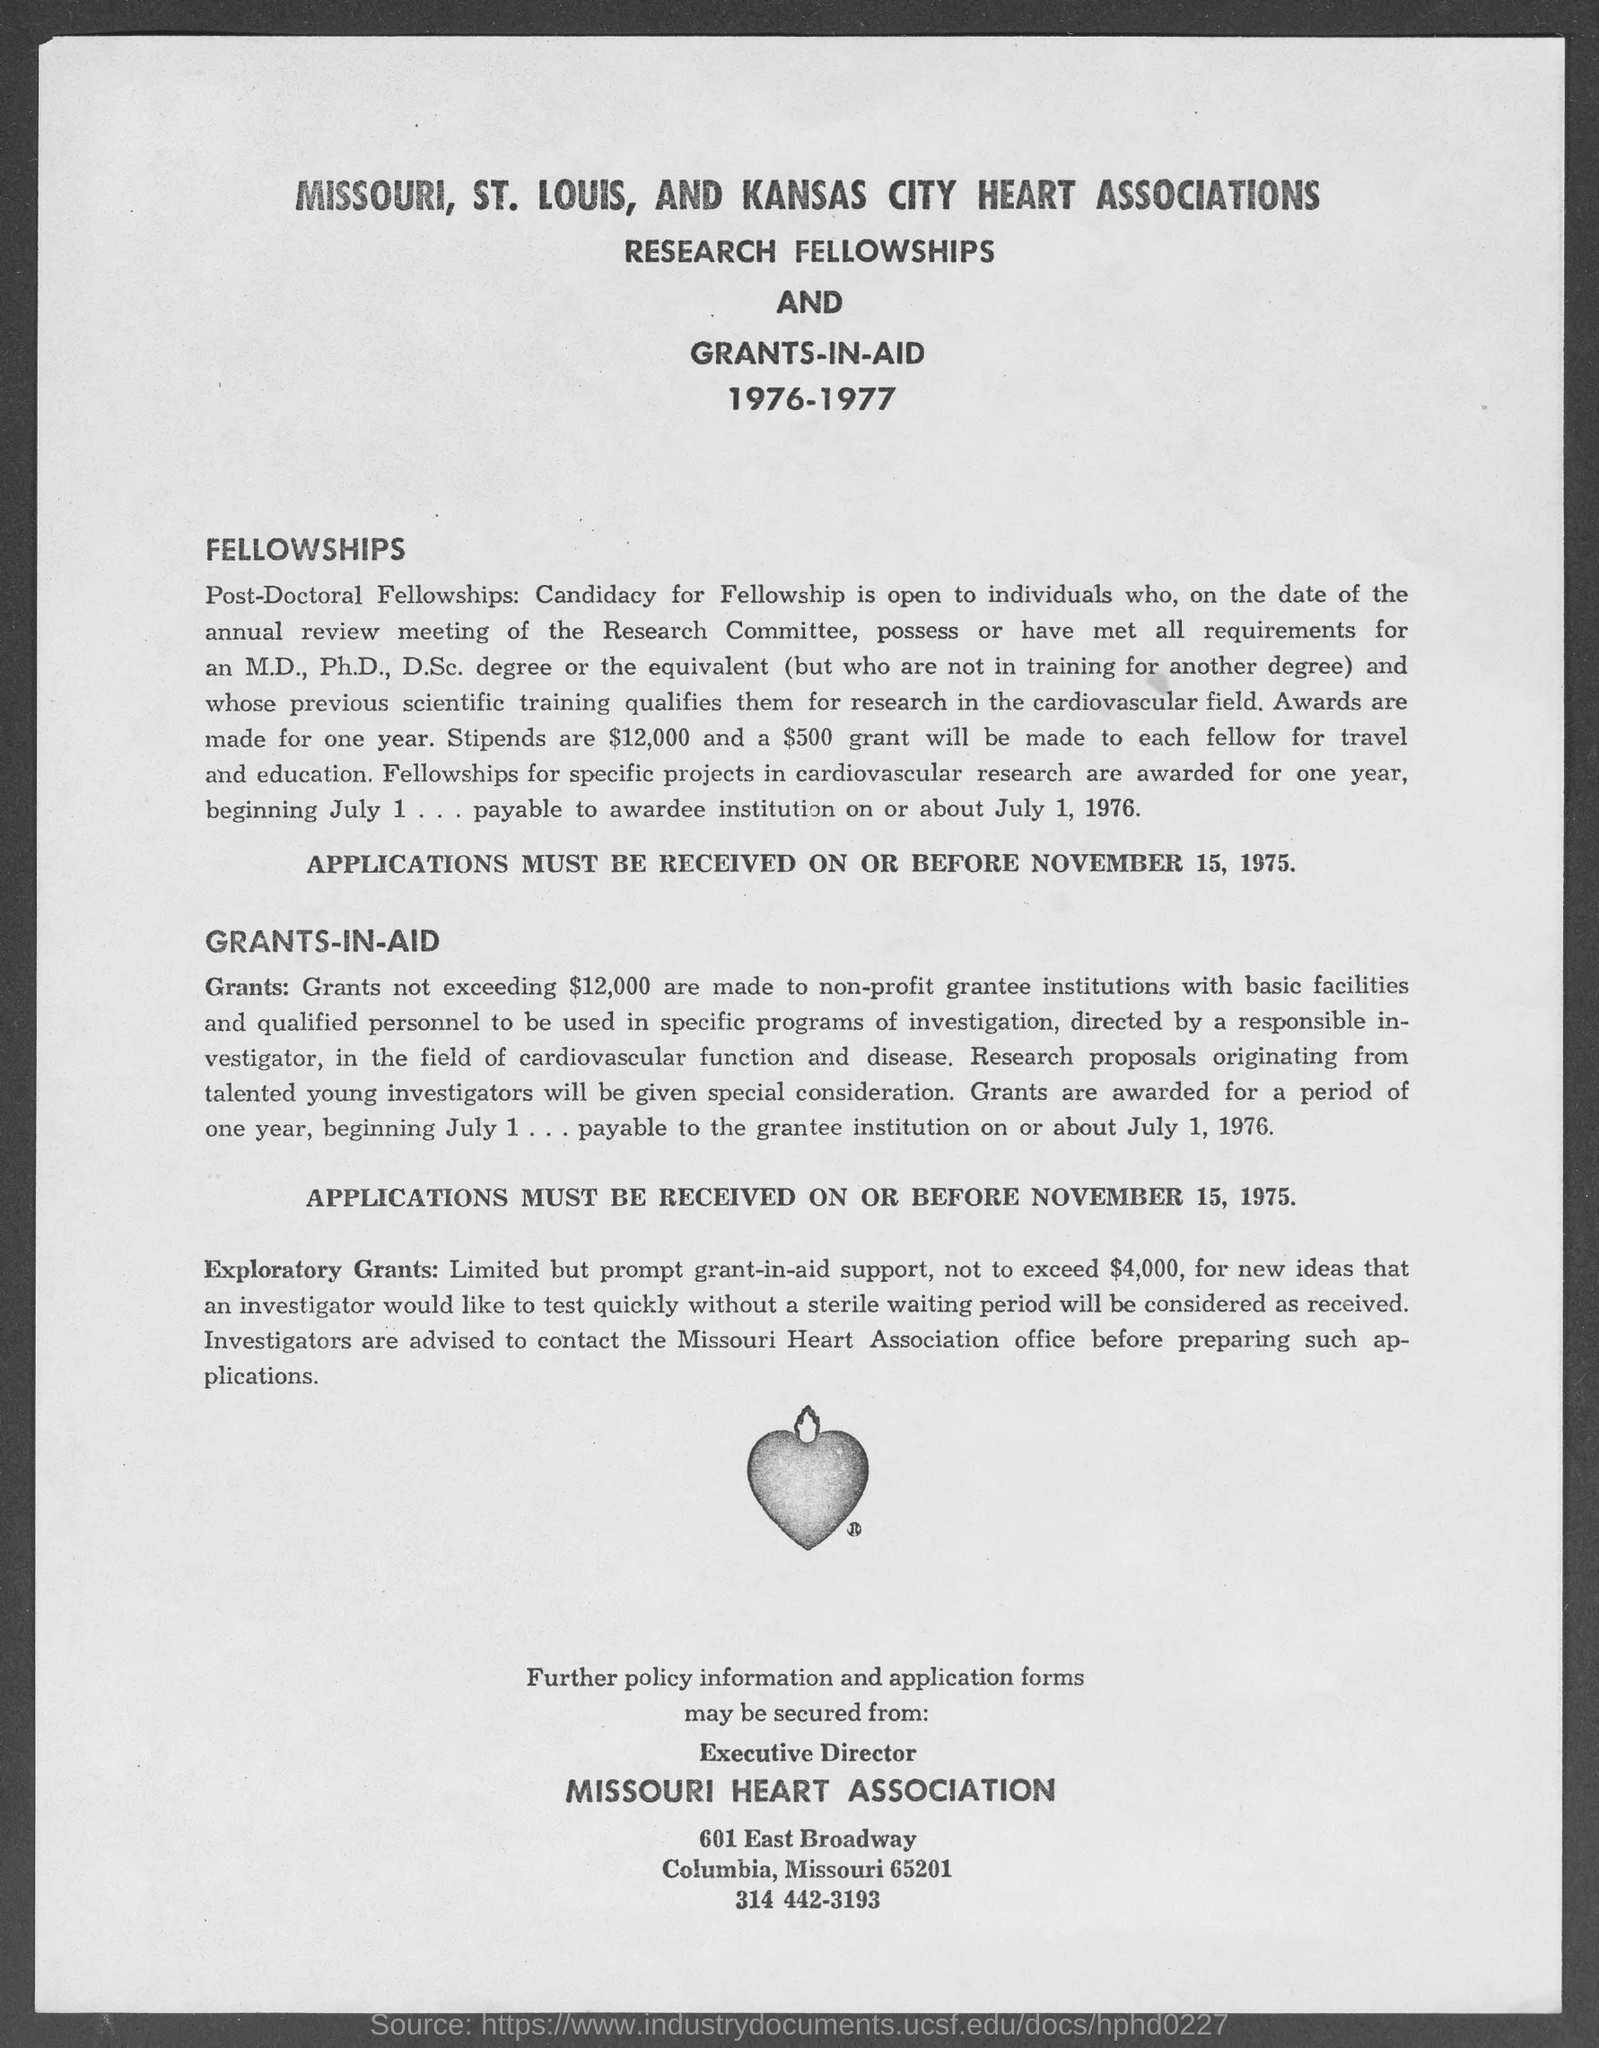What amount exploratory grants must not exceed?
Provide a short and direct response. $4,000. 